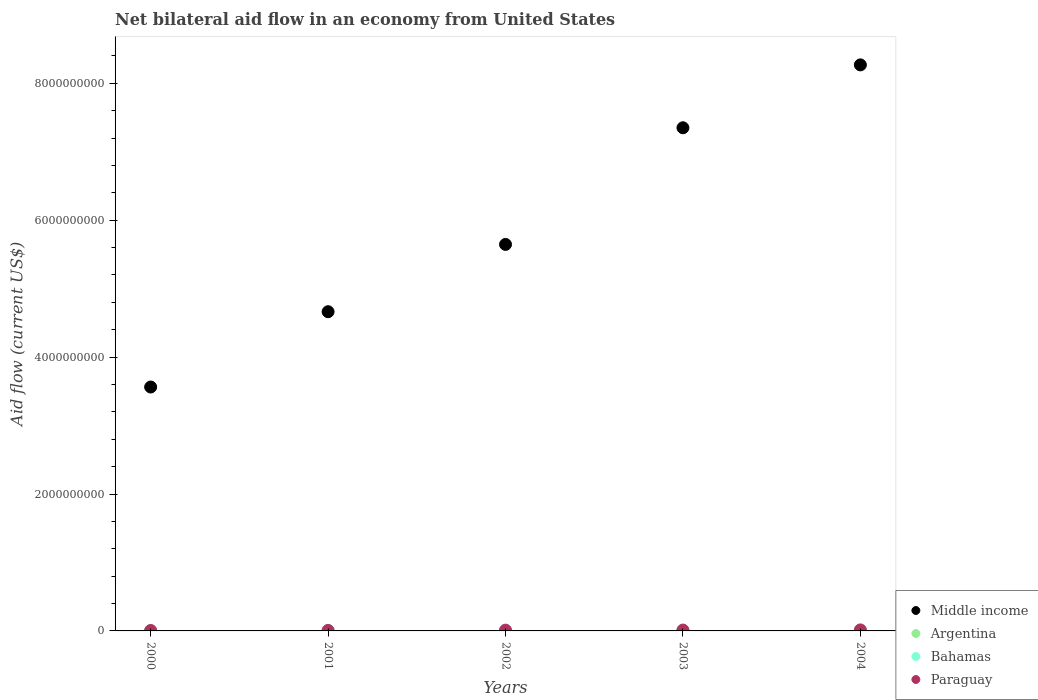Is the number of dotlines equal to the number of legend labels?
Your answer should be very brief. No. What is the net bilateral aid flow in Middle income in 2000?
Provide a short and direct response. 3.56e+09. Across all years, what is the maximum net bilateral aid flow in Argentina?
Offer a very short reply. 1.04e+07. Across all years, what is the minimum net bilateral aid flow in Middle income?
Give a very brief answer. 3.56e+09. What is the total net bilateral aid flow in Middle income in the graph?
Your response must be concise. 2.95e+1. What is the difference between the net bilateral aid flow in Bahamas in 2000 and that in 2003?
Provide a short and direct response. -6.30e+05. What is the difference between the net bilateral aid flow in Bahamas in 2004 and the net bilateral aid flow in Argentina in 2001?
Your response must be concise. 6.23e+06. What is the average net bilateral aid flow in Argentina per year?
Your answer should be very brief. 2.76e+06. In the year 2002, what is the difference between the net bilateral aid flow in Argentina and net bilateral aid flow in Paraguay?
Keep it short and to the point. -9.63e+06. What is the ratio of the net bilateral aid flow in Bahamas in 2001 to that in 2004?
Your response must be concise. 1.14. Is the difference between the net bilateral aid flow in Argentina in 2003 and 2004 greater than the difference between the net bilateral aid flow in Paraguay in 2003 and 2004?
Your answer should be very brief. Yes. What is the difference between the highest and the second highest net bilateral aid flow in Argentina?
Your response must be concise. 8.55e+06. What is the difference between the highest and the lowest net bilateral aid flow in Middle income?
Offer a very short reply. 4.71e+09. Is it the case that in every year, the sum of the net bilateral aid flow in Bahamas and net bilateral aid flow in Paraguay  is greater than the sum of net bilateral aid flow in Argentina and net bilateral aid flow in Middle income?
Your answer should be compact. No. Is the net bilateral aid flow in Middle income strictly greater than the net bilateral aid flow in Bahamas over the years?
Give a very brief answer. Yes. How many years are there in the graph?
Provide a succinct answer. 5. Does the graph contain grids?
Your response must be concise. No. How are the legend labels stacked?
Your answer should be very brief. Vertical. What is the title of the graph?
Your response must be concise. Net bilateral aid flow in an economy from United States. Does "Barbados" appear as one of the legend labels in the graph?
Give a very brief answer. No. What is the label or title of the X-axis?
Provide a succinct answer. Years. What is the label or title of the Y-axis?
Keep it short and to the point. Aid flow (current US$). What is the Aid flow (current US$) of Middle income in 2000?
Give a very brief answer. 3.56e+09. What is the Aid flow (current US$) of Argentina in 2000?
Keep it short and to the point. 0. What is the Aid flow (current US$) in Bahamas in 2000?
Give a very brief answer. 5.18e+06. What is the Aid flow (current US$) in Paraguay in 2000?
Offer a terse response. 6.41e+06. What is the Aid flow (current US$) of Middle income in 2001?
Offer a terse response. 4.66e+09. What is the Aid flow (current US$) of Argentina in 2001?
Your answer should be very brief. 0. What is the Aid flow (current US$) in Bahamas in 2001?
Keep it short and to the point. 7.13e+06. What is the Aid flow (current US$) in Paraguay in 2001?
Offer a very short reply. 6.96e+06. What is the Aid flow (current US$) of Middle income in 2002?
Offer a very short reply. 5.65e+09. What is the Aid flow (current US$) of Argentina in 2002?
Your answer should be very brief. 1.61e+06. What is the Aid flow (current US$) of Bahamas in 2002?
Provide a short and direct response. 6.92e+06. What is the Aid flow (current US$) in Paraguay in 2002?
Provide a succinct answer. 1.12e+07. What is the Aid flow (current US$) in Middle income in 2003?
Offer a very short reply. 7.35e+09. What is the Aid flow (current US$) of Argentina in 2003?
Your response must be concise. 1.04e+07. What is the Aid flow (current US$) in Bahamas in 2003?
Give a very brief answer. 5.81e+06. What is the Aid flow (current US$) in Paraguay in 2003?
Your answer should be very brief. 1.22e+07. What is the Aid flow (current US$) in Middle income in 2004?
Offer a terse response. 8.27e+09. What is the Aid flow (current US$) in Argentina in 2004?
Give a very brief answer. 1.82e+06. What is the Aid flow (current US$) of Bahamas in 2004?
Make the answer very short. 6.23e+06. What is the Aid flow (current US$) in Paraguay in 2004?
Your answer should be compact. 1.48e+07. Across all years, what is the maximum Aid flow (current US$) in Middle income?
Provide a succinct answer. 8.27e+09. Across all years, what is the maximum Aid flow (current US$) of Argentina?
Give a very brief answer. 1.04e+07. Across all years, what is the maximum Aid flow (current US$) of Bahamas?
Provide a short and direct response. 7.13e+06. Across all years, what is the maximum Aid flow (current US$) of Paraguay?
Your response must be concise. 1.48e+07. Across all years, what is the minimum Aid flow (current US$) of Middle income?
Ensure brevity in your answer.  3.56e+09. Across all years, what is the minimum Aid flow (current US$) of Argentina?
Make the answer very short. 0. Across all years, what is the minimum Aid flow (current US$) in Bahamas?
Provide a short and direct response. 5.18e+06. Across all years, what is the minimum Aid flow (current US$) in Paraguay?
Give a very brief answer. 6.41e+06. What is the total Aid flow (current US$) of Middle income in the graph?
Provide a succinct answer. 2.95e+1. What is the total Aid flow (current US$) of Argentina in the graph?
Provide a succinct answer. 1.38e+07. What is the total Aid flow (current US$) in Bahamas in the graph?
Keep it short and to the point. 3.13e+07. What is the total Aid flow (current US$) of Paraguay in the graph?
Make the answer very short. 5.16e+07. What is the difference between the Aid flow (current US$) in Middle income in 2000 and that in 2001?
Ensure brevity in your answer.  -1.10e+09. What is the difference between the Aid flow (current US$) of Bahamas in 2000 and that in 2001?
Keep it short and to the point. -1.95e+06. What is the difference between the Aid flow (current US$) of Paraguay in 2000 and that in 2001?
Your answer should be very brief. -5.50e+05. What is the difference between the Aid flow (current US$) of Middle income in 2000 and that in 2002?
Your answer should be very brief. -2.08e+09. What is the difference between the Aid flow (current US$) in Bahamas in 2000 and that in 2002?
Your answer should be compact. -1.74e+06. What is the difference between the Aid flow (current US$) in Paraguay in 2000 and that in 2002?
Provide a succinct answer. -4.83e+06. What is the difference between the Aid flow (current US$) in Middle income in 2000 and that in 2003?
Give a very brief answer. -3.79e+09. What is the difference between the Aid flow (current US$) of Bahamas in 2000 and that in 2003?
Offer a very short reply. -6.30e+05. What is the difference between the Aid flow (current US$) in Paraguay in 2000 and that in 2003?
Your answer should be very brief. -5.76e+06. What is the difference between the Aid flow (current US$) in Middle income in 2000 and that in 2004?
Give a very brief answer. -4.71e+09. What is the difference between the Aid flow (current US$) of Bahamas in 2000 and that in 2004?
Ensure brevity in your answer.  -1.05e+06. What is the difference between the Aid flow (current US$) in Paraguay in 2000 and that in 2004?
Make the answer very short. -8.42e+06. What is the difference between the Aid flow (current US$) of Middle income in 2001 and that in 2002?
Give a very brief answer. -9.83e+08. What is the difference between the Aid flow (current US$) of Bahamas in 2001 and that in 2002?
Offer a very short reply. 2.10e+05. What is the difference between the Aid flow (current US$) of Paraguay in 2001 and that in 2002?
Provide a succinct answer. -4.28e+06. What is the difference between the Aid flow (current US$) in Middle income in 2001 and that in 2003?
Offer a very short reply. -2.69e+09. What is the difference between the Aid flow (current US$) of Bahamas in 2001 and that in 2003?
Provide a short and direct response. 1.32e+06. What is the difference between the Aid flow (current US$) in Paraguay in 2001 and that in 2003?
Your answer should be very brief. -5.21e+06. What is the difference between the Aid flow (current US$) of Middle income in 2001 and that in 2004?
Offer a terse response. -3.61e+09. What is the difference between the Aid flow (current US$) in Bahamas in 2001 and that in 2004?
Offer a terse response. 9.00e+05. What is the difference between the Aid flow (current US$) in Paraguay in 2001 and that in 2004?
Provide a short and direct response. -7.87e+06. What is the difference between the Aid flow (current US$) in Middle income in 2002 and that in 2003?
Your answer should be very brief. -1.70e+09. What is the difference between the Aid flow (current US$) in Argentina in 2002 and that in 2003?
Give a very brief answer. -8.76e+06. What is the difference between the Aid flow (current US$) in Bahamas in 2002 and that in 2003?
Provide a succinct answer. 1.11e+06. What is the difference between the Aid flow (current US$) in Paraguay in 2002 and that in 2003?
Your answer should be very brief. -9.30e+05. What is the difference between the Aid flow (current US$) in Middle income in 2002 and that in 2004?
Give a very brief answer. -2.62e+09. What is the difference between the Aid flow (current US$) in Argentina in 2002 and that in 2004?
Keep it short and to the point. -2.10e+05. What is the difference between the Aid flow (current US$) in Bahamas in 2002 and that in 2004?
Offer a terse response. 6.90e+05. What is the difference between the Aid flow (current US$) of Paraguay in 2002 and that in 2004?
Ensure brevity in your answer.  -3.59e+06. What is the difference between the Aid flow (current US$) in Middle income in 2003 and that in 2004?
Offer a very short reply. -9.19e+08. What is the difference between the Aid flow (current US$) of Argentina in 2003 and that in 2004?
Make the answer very short. 8.55e+06. What is the difference between the Aid flow (current US$) of Bahamas in 2003 and that in 2004?
Offer a terse response. -4.20e+05. What is the difference between the Aid flow (current US$) of Paraguay in 2003 and that in 2004?
Offer a very short reply. -2.66e+06. What is the difference between the Aid flow (current US$) in Middle income in 2000 and the Aid flow (current US$) in Bahamas in 2001?
Ensure brevity in your answer.  3.56e+09. What is the difference between the Aid flow (current US$) in Middle income in 2000 and the Aid flow (current US$) in Paraguay in 2001?
Provide a succinct answer. 3.56e+09. What is the difference between the Aid flow (current US$) in Bahamas in 2000 and the Aid flow (current US$) in Paraguay in 2001?
Provide a succinct answer. -1.78e+06. What is the difference between the Aid flow (current US$) of Middle income in 2000 and the Aid flow (current US$) of Argentina in 2002?
Ensure brevity in your answer.  3.56e+09. What is the difference between the Aid flow (current US$) of Middle income in 2000 and the Aid flow (current US$) of Bahamas in 2002?
Your answer should be very brief. 3.56e+09. What is the difference between the Aid flow (current US$) in Middle income in 2000 and the Aid flow (current US$) in Paraguay in 2002?
Offer a terse response. 3.55e+09. What is the difference between the Aid flow (current US$) in Bahamas in 2000 and the Aid flow (current US$) in Paraguay in 2002?
Make the answer very short. -6.06e+06. What is the difference between the Aid flow (current US$) in Middle income in 2000 and the Aid flow (current US$) in Argentina in 2003?
Provide a succinct answer. 3.55e+09. What is the difference between the Aid flow (current US$) of Middle income in 2000 and the Aid flow (current US$) of Bahamas in 2003?
Your response must be concise. 3.56e+09. What is the difference between the Aid flow (current US$) of Middle income in 2000 and the Aid flow (current US$) of Paraguay in 2003?
Your response must be concise. 3.55e+09. What is the difference between the Aid flow (current US$) in Bahamas in 2000 and the Aid flow (current US$) in Paraguay in 2003?
Your answer should be very brief. -6.99e+06. What is the difference between the Aid flow (current US$) of Middle income in 2000 and the Aid flow (current US$) of Argentina in 2004?
Ensure brevity in your answer.  3.56e+09. What is the difference between the Aid flow (current US$) of Middle income in 2000 and the Aid flow (current US$) of Bahamas in 2004?
Your answer should be compact. 3.56e+09. What is the difference between the Aid flow (current US$) of Middle income in 2000 and the Aid flow (current US$) of Paraguay in 2004?
Provide a succinct answer. 3.55e+09. What is the difference between the Aid flow (current US$) of Bahamas in 2000 and the Aid flow (current US$) of Paraguay in 2004?
Ensure brevity in your answer.  -9.65e+06. What is the difference between the Aid flow (current US$) of Middle income in 2001 and the Aid flow (current US$) of Argentina in 2002?
Give a very brief answer. 4.66e+09. What is the difference between the Aid flow (current US$) of Middle income in 2001 and the Aid flow (current US$) of Bahamas in 2002?
Keep it short and to the point. 4.66e+09. What is the difference between the Aid flow (current US$) of Middle income in 2001 and the Aid flow (current US$) of Paraguay in 2002?
Provide a succinct answer. 4.65e+09. What is the difference between the Aid flow (current US$) of Bahamas in 2001 and the Aid flow (current US$) of Paraguay in 2002?
Provide a short and direct response. -4.11e+06. What is the difference between the Aid flow (current US$) in Middle income in 2001 and the Aid flow (current US$) in Argentina in 2003?
Make the answer very short. 4.65e+09. What is the difference between the Aid flow (current US$) in Middle income in 2001 and the Aid flow (current US$) in Bahamas in 2003?
Give a very brief answer. 4.66e+09. What is the difference between the Aid flow (current US$) of Middle income in 2001 and the Aid flow (current US$) of Paraguay in 2003?
Provide a succinct answer. 4.65e+09. What is the difference between the Aid flow (current US$) in Bahamas in 2001 and the Aid flow (current US$) in Paraguay in 2003?
Make the answer very short. -5.04e+06. What is the difference between the Aid flow (current US$) of Middle income in 2001 and the Aid flow (current US$) of Argentina in 2004?
Provide a succinct answer. 4.66e+09. What is the difference between the Aid flow (current US$) of Middle income in 2001 and the Aid flow (current US$) of Bahamas in 2004?
Ensure brevity in your answer.  4.66e+09. What is the difference between the Aid flow (current US$) of Middle income in 2001 and the Aid flow (current US$) of Paraguay in 2004?
Provide a short and direct response. 4.65e+09. What is the difference between the Aid flow (current US$) in Bahamas in 2001 and the Aid flow (current US$) in Paraguay in 2004?
Your answer should be very brief. -7.70e+06. What is the difference between the Aid flow (current US$) of Middle income in 2002 and the Aid flow (current US$) of Argentina in 2003?
Keep it short and to the point. 5.64e+09. What is the difference between the Aid flow (current US$) of Middle income in 2002 and the Aid flow (current US$) of Bahamas in 2003?
Offer a very short reply. 5.64e+09. What is the difference between the Aid flow (current US$) in Middle income in 2002 and the Aid flow (current US$) in Paraguay in 2003?
Keep it short and to the point. 5.63e+09. What is the difference between the Aid flow (current US$) in Argentina in 2002 and the Aid flow (current US$) in Bahamas in 2003?
Ensure brevity in your answer.  -4.20e+06. What is the difference between the Aid flow (current US$) in Argentina in 2002 and the Aid flow (current US$) in Paraguay in 2003?
Make the answer very short. -1.06e+07. What is the difference between the Aid flow (current US$) in Bahamas in 2002 and the Aid flow (current US$) in Paraguay in 2003?
Offer a terse response. -5.25e+06. What is the difference between the Aid flow (current US$) of Middle income in 2002 and the Aid flow (current US$) of Argentina in 2004?
Make the answer very short. 5.64e+09. What is the difference between the Aid flow (current US$) of Middle income in 2002 and the Aid flow (current US$) of Bahamas in 2004?
Offer a terse response. 5.64e+09. What is the difference between the Aid flow (current US$) in Middle income in 2002 and the Aid flow (current US$) in Paraguay in 2004?
Offer a terse response. 5.63e+09. What is the difference between the Aid flow (current US$) in Argentina in 2002 and the Aid flow (current US$) in Bahamas in 2004?
Offer a very short reply. -4.62e+06. What is the difference between the Aid flow (current US$) of Argentina in 2002 and the Aid flow (current US$) of Paraguay in 2004?
Provide a short and direct response. -1.32e+07. What is the difference between the Aid flow (current US$) of Bahamas in 2002 and the Aid flow (current US$) of Paraguay in 2004?
Offer a very short reply. -7.91e+06. What is the difference between the Aid flow (current US$) in Middle income in 2003 and the Aid flow (current US$) in Argentina in 2004?
Your response must be concise. 7.35e+09. What is the difference between the Aid flow (current US$) in Middle income in 2003 and the Aid flow (current US$) in Bahamas in 2004?
Give a very brief answer. 7.34e+09. What is the difference between the Aid flow (current US$) in Middle income in 2003 and the Aid flow (current US$) in Paraguay in 2004?
Offer a terse response. 7.34e+09. What is the difference between the Aid flow (current US$) in Argentina in 2003 and the Aid flow (current US$) in Bahamas in 2004?
Your answer should be compact. 4.14e+06. What is the difference between the Aid flow (current US$) in Argentina in 2003 and the Aid flow (current US$) in Paraguay in 2004?
Your answer should be very brief. -4.46e+06. What is the difference between the Aid flow (current US$) of Bahamas in 2003 and the Aid flow (current US$) of Paraguay in 2004?
Offer a very short reply. -9.02e+06. What is the average Aid flow (current US$) in Middle income per year?
Give a very brief answer. 5.90e+09. What is the average Aid flow (current US$) in Argentina per year?
Give a very brief answer. 2.76e+06. What is the average Aid flow (current US$) of Bahamas per year?
Provide a short and direct response. 6.25e+06. What is the average Aid flow (current US$) in Paraguay per year?
Your answer should be compact. 1.03e+07. In the year 2000, what is the difference between the Aid flow (current US$) of Middle income and Aid flow (current US$) of Bahamas?
Give a very brief answer. 3.56e+09. In the year 2000, what is the difference between the Aid flow (current US$) in Middle income and Aid flow (current US$) in Paraguay?
Provide a succinct answer. 3.56e+09. In the year 2000, what is the difference between the Aid flow (current US$) in Bahamas and Aid flow (current US$) in Paraguay?
Keep it short and to the point. -1.23e+06. In the year 2001, what is the difference between the Aid flow (current US$) of Middle income and Aid flow (current US$) of Bahamas?
Ensure brevity in your answer.  4.66e+09. In the year 2001, what is the difference between the Aid flow (current US$) in Middle income and Aid flow (current US$) in Paraguay?
Your answer should be compact. 4.66e+09. In the year 2002, what is the difference between the Aid flow (current US$) in Middle income and Aid flow (current US$) in Argentina?
Your answer should be compact. 5.64e+09. In the year 2002, what is the difference between the Aid flow (current US$) of Middle income and Aid flow (current US$) of Bahamas?
Ensure brevity in your answer.  5.64e+09. In the year 2002, what is the difference between the Aid flow (current US$) of Middle income and Aid flow (current US$) of Paraguay?
Give a very brief answer. 5.64e+09. In the year 2002, what is the difference between the Aid flow (current US$) in Argentina and Aid flow (current US$) in Bahamas?
Provide a short and direct response. -5.31e+06. In the year 2002, what is the difference between the Aid flow (current US$) of Argentina and Aid flow (current US$) of Paraguay?
Make the answer very short. -9.63e+06. In the year 2002, what is the difference between the Aid flow (current US$) in Bahamas and Aid flow (current US$) in Paraguay?
Your answer should be very brief. -4.32e+06. In the year 2003, what is the difference between the Aid flow (current US$) in Middle income and Aid flow (current US$) in Argentina?
Ensure brevity in your answer.  7.34e+09. In the year 2003, what is the difference between the Aid flow (current US$) of Middle income and Aid flow (current US$) of Bahamas?
Your answer should be compact. 7.34e+09. In the year 2003, what is the difference between the Aid flow (current US$) of Middle income and Aid flow (current US$) of Paraguay?
Offer a terse response. 7.34e+09. In the year 2003, what is the difference between the Aid flow (current US$) of Argentina and Aid flow (current US$) of Bahamas?
Your response must be concise. 4.56e+06. In the year 2003, what is the difference between the Aid flow (current US$) in Argentina and Aid flow (current US$) in Paraguay?
Keep it short and to the point. -1.80e+06. In the year 2003, what is the difference between the Aid flow (current US$) in Bahamas and Aid flow (current US$) in Paraguay?
Make the answer very short. -6.36e+06. In the year 2004, what is the difference between the Aid flow (current US$) of Middle income and Aid flow (current US$) of Argentina?
Ensure brevity in your answer.  8.27e+09. In the year 2004, what is the difference between the Aid flow (current US$) in Middle income and Aid flow (current US$) in Bahamas?
Provide a succinct answer. 8.26e+09. In the year 2004, what is the difference between the Aid flow (current US$) in Middle income and Aid flow (current US$) in Paraguay?
Provide a short and direct response. 8.25e+09. In the year 2004, what is the difference between the Aid flow (current US$) of Argentina and Aid flow (current US$) of Bahamas?
Keep it short and to the point. -4.41e+06. In the year 2004, what is the difference between the Aid flow (current US$) of Argentina and Aid flow (current US$) of Paraguay?
Make the answer very short. -1.30e+07. In the year 2004, what is the difference between the Aid flow (current US$) of Bahamas and Aid flow (current US$) of Paraguay?
Your response must be concise. -8.60e+06. What is the ratio of the Aid flow (current US$) of Middle income in 2000 to that in 2001?
Offer a terse response. 0.76. What is the ratio of the Aid flow (current US$) in Bahamas in 2000 to that in 2001?
Give a very brief answer. 0.73. What is the ratio of the Aid flow (current US$) in Paraguay in 2000 to that in 2001?
Offer a very short reply. 0.92. What is the ratio of the Aid flow (current US$) of Middle income in 2000 to that in 2002?
Offer a terse response. 0.63. What is the ratio of the Aid flow (current US$) of Bahamas in 2000 to that in 2002?
Offer a very short reply. 0.75. What is the ratio of the Aid flow (current US$) in Paraguay in 2000 to that in 2002?
Your response must be concise. 0.57. What is the ratio of the Aid flow (current US$) in Middle income in 2000 to that in 2003?
Give a very brief answer. 0.48. What is the ratio of the Aid flow (current US$) in Bahamas in 2000 to that in 2003?
Your answer should be compact. 0.89. What is the ratio of the Aid flow (current US$) in Paraguay in 2000 to that in 2003?
Make the answer very short. 0.53. What is the ratio of the Aid flow (current US$) in Middle income in 2000 to that in 2004?
Make the answer very short. 0.43. What is the ratio of the Aid flow (current US$) of Bahamas in 2000 to that in 2004?
Your answer should be very brief. 0.83. What is the ratio of the Aid flow (current US$) of Paraguay in 2000 to that in 2004?
Offer a very short reply. 0.43. What is the ratio of the Aid flow (current US$) of Middle income in 2001 to that in 2002?
Keep it short and to the point. 0.83. What is the ratio of the Aid flow (current US$) of Bahamas in 2001 to that in 2002?
Provide a succinct answer. 1.03. What is the ratio of the Aid flow (current US$) in Paraguay in 2001 to that in 2002?
Make the answer very short. 0.62. What is the ratio of the Aid flow (current US$) in Middle income in 2001 to that in 2003?
Your answer should be very brief. 0.63. What is the ratio of the Aid flow (current US$) in Bahamas in 2001 to that in 2003?
Provide a short and direct response. 1.23. What is the ratio of the Aid flow (current US$) in Paraguay in 2001 to that in 2003?
Your answer should be very brief. 0.57. What is the ratio of the Aid flow (current US$) of Middle income in 2001 to that in 2004?
Ensure brevity in your answer.  0.56. What is the ratio of the Aid flow (current US$) of Bahamas in 2001 to that in 2004?
Give a very brief answer. 1.14. What is the ratio of the Aid flow (current US$) of Paraguay in 2001 to that in 2004?
Provide a short and direct response. 0.47. What is the ratio of the Aid flow (current US$) in Middle income in 2002 to that in 2003?
Keep it short and to the point. 0.77. What is the ratio of the Aid flow (current US$) in Argentina in 2002 to that in 2003?
Keep it short and to the point. 0.16. What is the ratio of the Aid flow (current US$) in Bahamas in 2002 to that in 2003?
Give a very brief answer. 1.19. What is the ratio of the Aid flow (current US$) in Paraguay in 2002 to that in 2003?
Make the answer very short. 0.92. What is the ratio of the Aid flow (current US$) of Middle income in 2002 to that in 2004?
Offer a very short reply. 0.68. What is the ratio of the Aid flow (current US$) of Argentina in 2002 to that in 2004?
Your answer should be very brief. 0.88. What is the ratio of the Aid flow (current US$) in Bahamas in 2002 to that in 2004?
Offer a terse response. 1.11. What is the ratio of the Aid flow (current US$) of Paraguay in 2002 to that in 2004?
Offer a very short reply. 0.76. What is the ratio of the Aid flow (current US$) in Argentina in 2003 to that in 2004?
Keep it short and to the point. 5.7. What is the ratio of the Aid flow (current US$) of Bahamas in 2003 to that in 2004?
Keep it short and to the point. 0.93. What is the ratio of the Aid flow (current US$) in Paraguay in 2003 to that in 2004?
Ensure brevity in your answer.  0.82. What is the difference between the highest and the second highest Aid flow (current US$) in Middle income?
Keep it short and to the point. 9.19e+08. What is the difference between the highest and the second highest Aid flow (current US$) of Argentina?
Make the answer very short. 8.55e+06. What is the difference between the highest and the second highest Aid flow (current US$) in Bahamas?
Make the answer very short. 2.10e+05. What is the difference between the highest and the second highest Aid flow (current US$) of Paraguay?
Offer a terse response. 2.66e+06. What is the difference between the highest and the lowest Aid flow (current US$) of Middle income?
Your answer should be very brief. 4.71e+09. What is the difference between the highest and the lowest Aid flow (current US$) in Argentina?
Give a very brief answer. 1.04e+07. What is the difference between the highest and the lowest Aid flow (current US$) in Bahamas?
Give a very brief answer. 1.95e+06. What is the difference between the highest and the lowest Aid flow (current US$) of Paraguay?
Your response must be concise. 8.42e+06. 